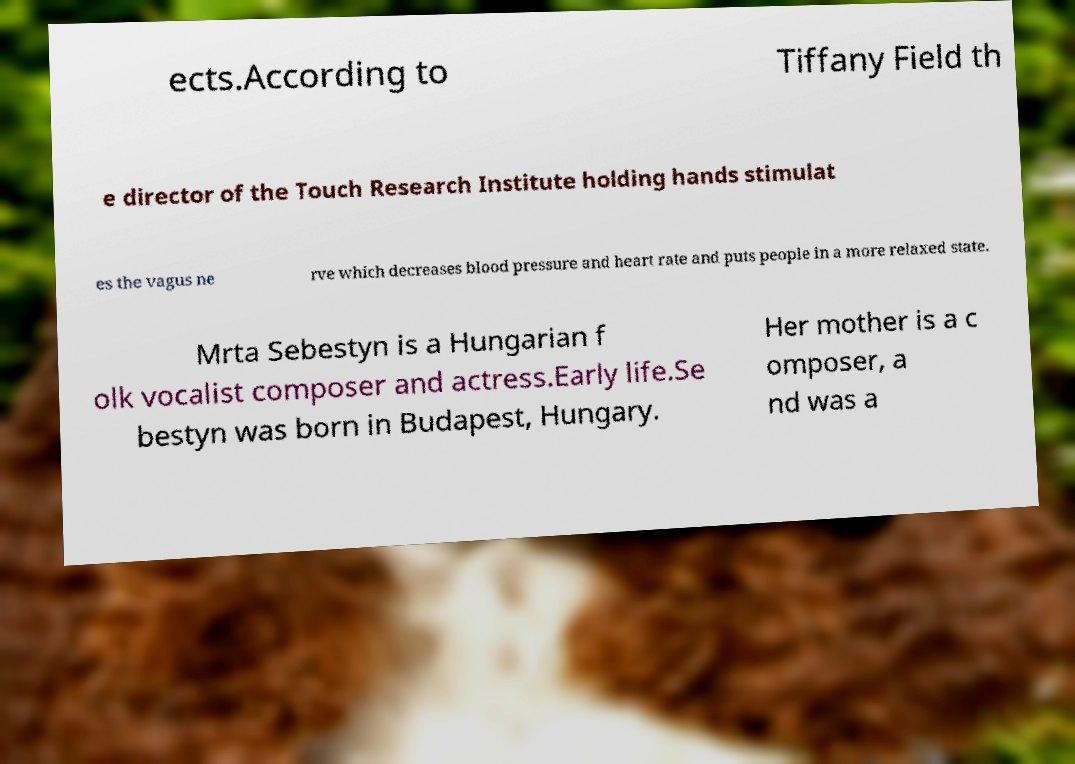For documentation purposes, I need the text within this image transcribed. Could you provide that? ects.According to Tiffany Field th e director of the Touch Research Institute holding hands stimulat es the vagus ne rve which decreases blood pressure and heart rate and puts people in a more relaxed state. Mrta Sebestyn is a Hungarian f olk vocalist composer and actress.Early life.Se bestyn was born in Budapest, Hungary. Her mother is a c omposer, a nd was a 